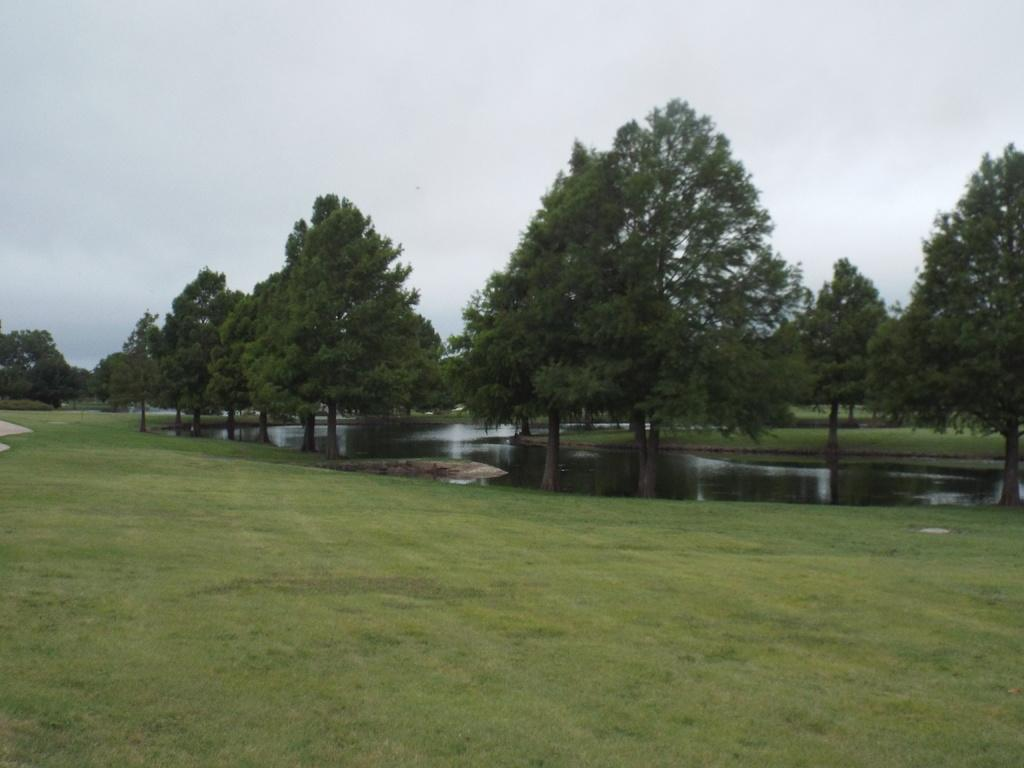What type of vegetation can be seen in the image? There are trees with branches and leaves in the image. What else can be seen on the ground in the image? There is grass visible in the image. What body of water is present in the image? There is a pond with water in the image. What is visible above the trees and pond in the image? The sky is visible in the image. What type of cabbage is being harvested by the governor in the image? There is no governor or cabbage present in the image. 